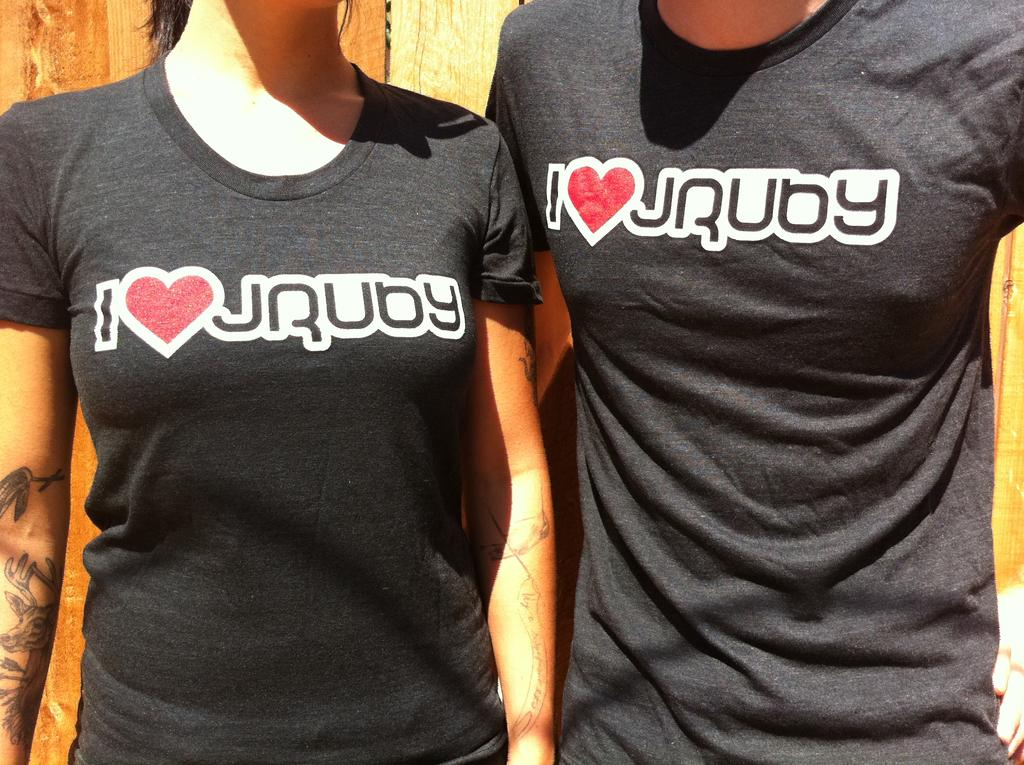<image>
Present a compact description of the photo's key features. a faceless man and woman wearing black tshirts that say i <3 jruby 